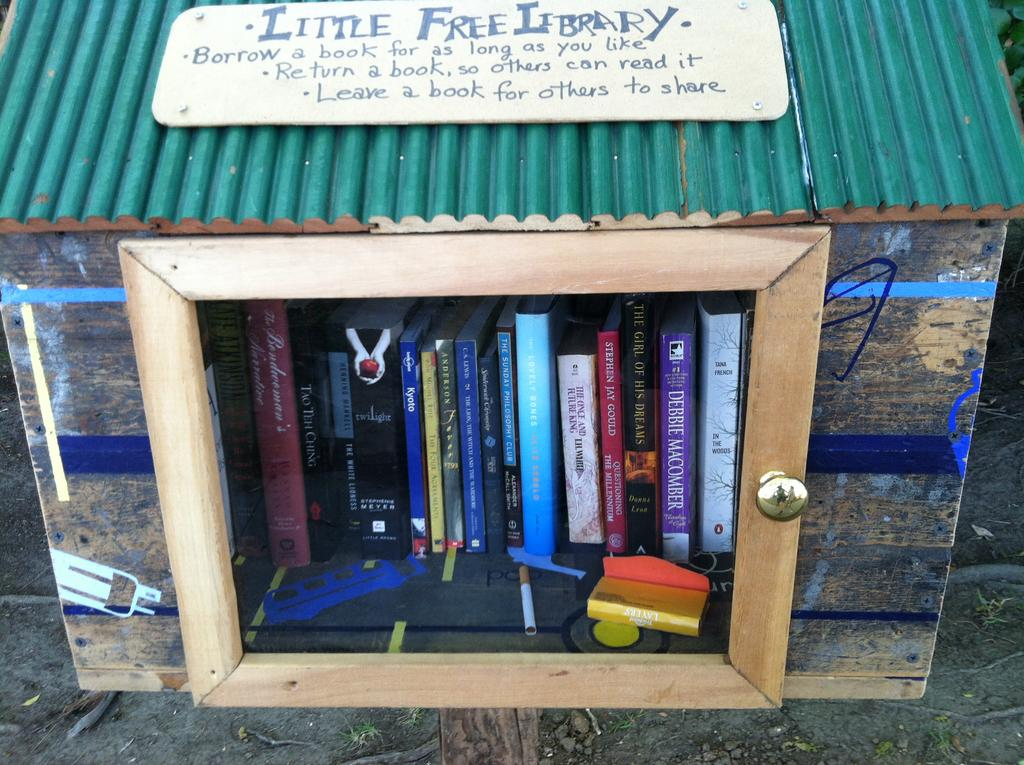<image>
Render a clear and concise summary of the photo. A little free library that allows people to borrow the books that they offer for any amount of time. 